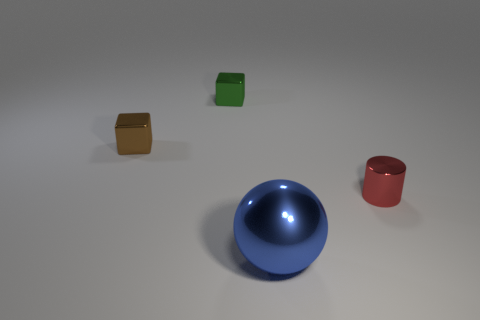Are there any other things that are the same size as the blue thing?
Ensure brevity in your answer.  No. Are the red cylinder that is in front of the small brown metal cube and the small block to the right of the brown object made of the same material?
Make the answer very short. Yes. What material is the brown object?
Keep it short and to the point. Metal. Are there more tiny shiny objects in front of the small cylinder than red shiny cylinders?
Your answer should be compact. No. What number of large blue metallic things are in front of the brown shiny cube in front of the tiny shiny block behind the brown thing?
Offer a very short reply. 1. There is a small thing that is left of the small shiny cylinder and in front of the tiny green cube; what material is it?
Offer a terse response. Metal. The shiny cylinder has what color?
Your answer should be compact. Red. Is the number of tiny green cubes that are to the right of the tiny red cylinder greater than the number of cylinders that are right of the brown cube?
Give a very brief answer. No. There is a object in front of the small red cylinder; what color is it?
Keep it short and to the point. Blue. Do the metallic object right of the large thing and the metallic object that is in front of the tiny metallic cylinder have the same size?
Offer a very short reply. No. 